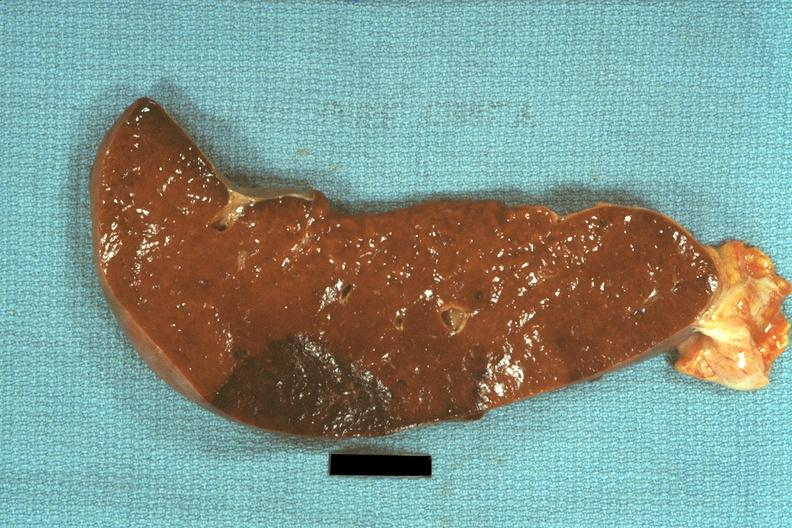s hematologic present?
Answer the question using a single word or phrase. Yes 